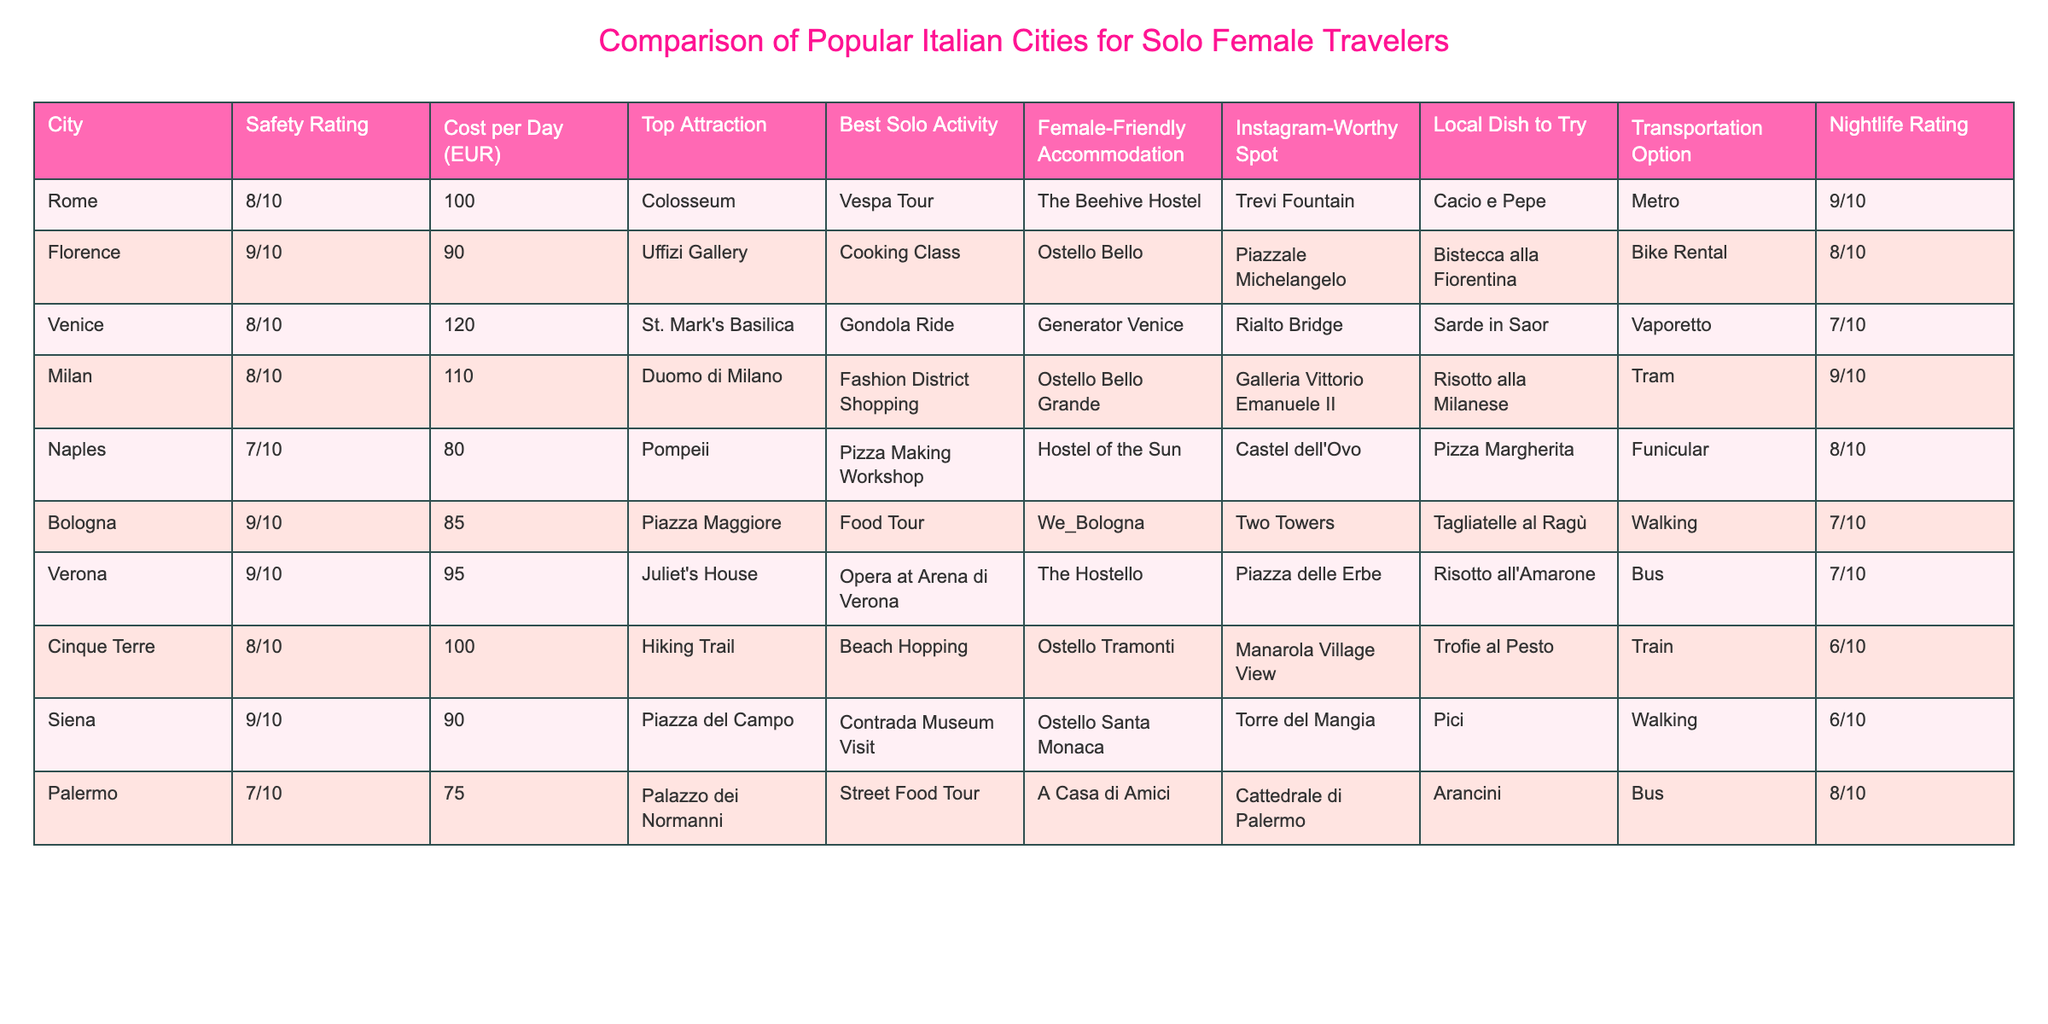What is the safety rating for Florence? The safety rating for Florence is stated directly in the table under the 'Safety Rating' column, where it shows a rating of 9/10.
Answer: 9/10 Which city has the highest nightlife rating? Looking at the 'Nightlife Rating' column, I can see that Milan has the highest nightlife rating at 9/10, compared to other cities.
Answer: Milan What is the average cost per day for the cities listed? To find the average cost per day, I sum the costs: (100 + 90 + 120 + 110 + 80 + 85 + 95 + 100 + 90 + 75) = 1,005. There are 10 cities, so the average cost is 1,005 / 10 = 100.5.
Answer: 100.5 Is Naples one of the cities with a female-friendly accommodation? Checking the 'Female-Friendly Accommodation' column for Naples, it shows 'Hostel of the Sun', indicating that it is a female-friendly place to stay.
Answer: Yes Which city has the top attraction of St. Mark's Basilica? According to the 'Top Attraction' column, Venice is listed as having St. Mark's Basilica as its top attraction.
Answer: Venice What is the safest city listed, and what is its cost per day? The safest city is Florence with a safety rating of 9/10. Its cost per day is 90 EUR, which is found under the respective columns.
Answer: Florence, 90 EUR How many cities have a nightlife rating of 7/10? By counting the entries in the 'Nightlife Rating' column, I find that three cities (Venice, Bologna, and Verona) have a nightlife rating of 7/10.
Answer: 3 Which city offers a cooking class as the best solo activity? Searching through the 'Best Solo Activity' column, I locate Florence, where the cooking class is indicated as the best solo activity.
Answer: Florence What percentage of the cities have significant Instagram-worthy spots (rated 8/10 or higher)? In the 'Instagram-Worthy Spot' column, both Milan (Galleria Vittorio Emanuele II) and Florence (Piazzale Michelangelo) have spots that could be considered significant. There are 2 out of 10 cities with a high rating, resulting in 20%.
Answer: 20% 